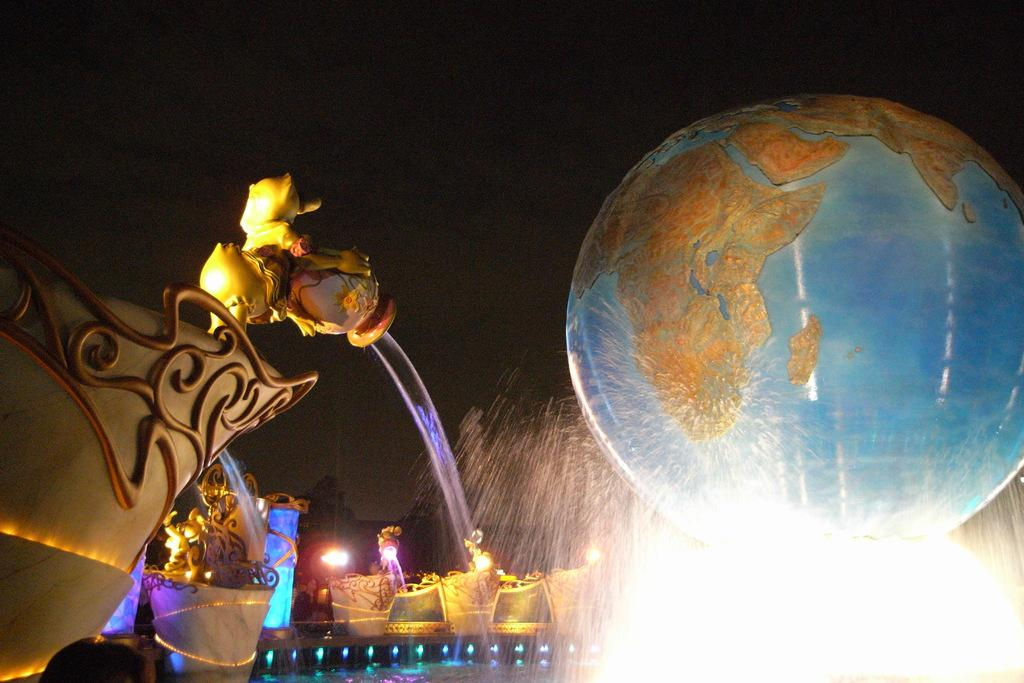What natural feature is the main subject of the image? There is a waterfall in the image. What object is located behind the waterfall? There is a globe behind the waterfall. What type of brick is used to construct the waterfall in the image? There is no mention of bricks or any construction materials in the image; it features a natural waterfall. 